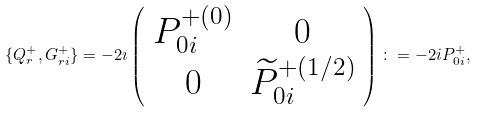Convert formula to latex. <formula><loc_0><loc_0><loc_500><loc_500>\{ Q ^ { + } _ { r } , G ^ { + } _ { r i } \} = - 2 \imath \left ( \begin{array} { c c c } P ^ { + ( 0 ) } _ { 0 i } & 0 \\ 0 & \widetilde { P } ^ { + ( 1 / 2 ) } _ { 0 i } \end{array} \right ) \colon = - 2 i { P ^ { + } _ { 0 i } } ,</formula> 